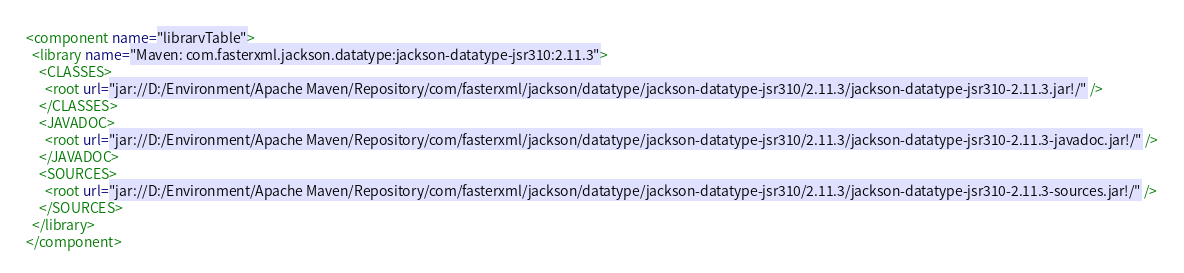Convert code to text. <code><loc_0><loc_0><loc_500><loc_500><_XML_><component name="libraryTable">
  <library name="Maven: com.fasterxml.jackson.datatype:jackson-datatype-jsr310:2.11.3">
    <CLASSES>
      <root url="jar://D:/Environment/Apache Maven/Repository/com/fasterxml/jackson/datatype/jackson-datatype-jsr310/2.11.3/jackson-datatype-jsr310-2.11.3.jar!/" />
    </CLASSES>
    <JAVADOC>
      <root url="jar://D:/Environment/Apache Maven/Repository/com/fasterxml/jackson/datatype/jackson-datatype-jsr310/2.11.3/jackson-datatype-jsr310-2.11.3-javadoc.jar!/" />
    </JAVADOC>
    <SOURCES>
      <root url="jar://D:/Environment/Apache Maven/Repository/com/fasterxml/jackson/datatype/jackson-datatype-jsr310/2.11.3/jackson-datatype-jsr310-2.11.3-sources.jar!/" />
    </SOURCES>
  </library>
</component></code> 